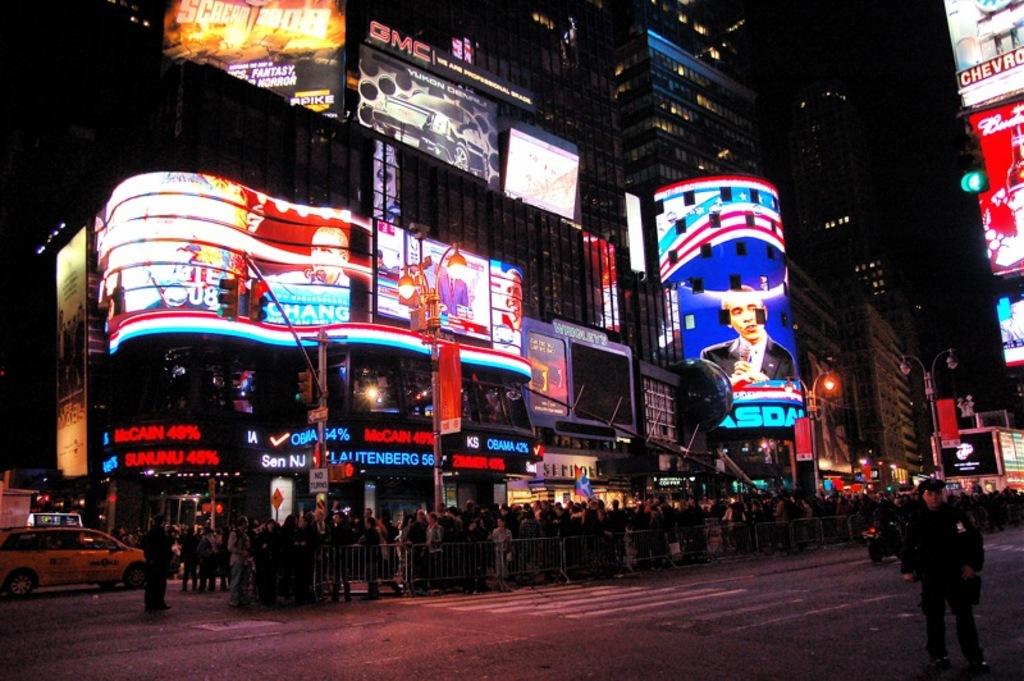What car manufacturer is mentioned at the top?
Your response must be concise. Gmc. 